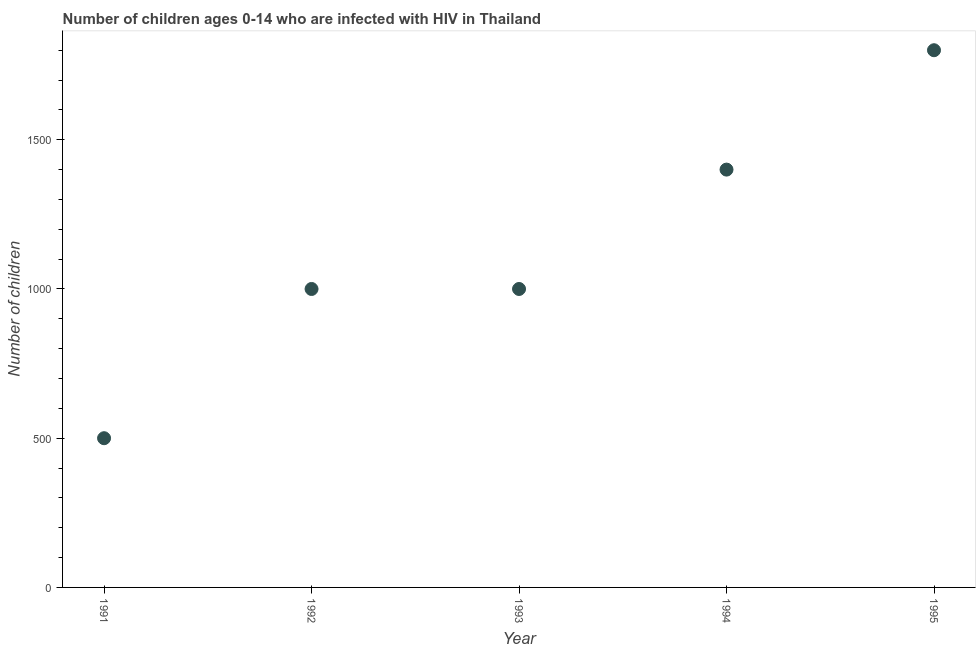What is the number of children living with hiv in 1994?
Keep it short and to the point. 1400. Across all years, what is the maximum number of children living with hiv?
Keep it short and to the point. 1800. Across all years, what is the minimum number of children living with hiv?
Make the answer very short. 500. What is the sum of the number of children living with hiv?
Provide a short and direct response. 5700. What is the difference between the number of children living with hiv in 1994 and 1995?
Offer a terse response. -400. What is the average number of children living with hiv per year?
Provide a succinct answer. 1140. In how many years, is the number of children living with hiv greater than 600 ?
Ensure brevity in your answer.  4. What is the ratio of the number of children living with hiv in 1992 to that in 1995?
Your response must be concise. 0.56. Is the difference between the number of children living with hiv in 1991 and 1995 greater than the difference between any two years?
Your answer should be compact. Yes. What is the difference between the highest and the second highest number of children living with hiv?
Offer a very short reply. 400. Is the sum of the number of children living with hiv in 1993 and 1994 greater than the maximum number of children living with hiv across all years?
Provide a succinct answer. Yes. What is the difference between the highest and the lowest number of children living with hiv?
Your answer should be compact. 1300. In how many years, is the number of children living with hiv greater than the average number of children living with hiv taken over all years?
Offer a very short reply. 2. Does the number of children living with hiv monotonically increase over the years?
Provide a short and direct response. No. How many years are there in the graph?
Keep it short and to the point. 5. What is the difference between two consecutive major ticks on the Y-axis?
Give a very brief answer. 500. Are the values on the major ticks of Y-axis written in scientific E-notation?
Keep it short and to the point. No. Does the graph contain grids?
Give a very brief answer. No. What is the title of the graph?
Your response must be concise. Number of children ages 0-14 who are infected with HIV in Thailand. What is the label or title of the Y-axis?
Keep it short and to the point. Number of children. What is the Number of children in 1992?
Offer a terse response. 1000. What is the Number of children in 1993?
Ensure brevity in your answer.  1000. What is the Number of children in 1994?
Your answer should be compact. 1400. What is the Number of children in 1995?
Keep it short and to the point. 1800. What is the difference between the Number of children in 1991 and 1992?
Make the answer very short. -500. What is the difference between the Number of children in 1991 and 1993?
Your answer should be compact. -500. What is the difference between the Number of children in 1991 and 1994?
Offer a very short reply. -900. What is the difference between the Number of children in 1991 and 1995?
Provide a succinct answer. -1300. What is the difference between the Number of children in 1992 and 1993?
Ensure brevity in your answer.  0. What is the difference between the Number of children in 1992 and 1994?
Provide a short and direct response. -400. What is the difference between the Number of children in 1992 and 1995?
Offer a very short reply. -800. What is the difference between the Number of children in 1993 and 1994?
Give a very brief answer. -400. What is the difference between the Number of children in 1993 and 1995?
Your answer should be compact. -800. What is the difference between the Number of children in 1994 and 1995?
Offer a very short reply. -400. What is the ratio of the Number of children in 1991 to that in 1994?
Your answer should be compact. 0.36. What is the ratio of the Number of children in 1991 to that in 1995?
Offer a very short reply. 0.28. What is the ratio of the Number of children in 1992 to that in 1993?
Keep it short and to the point. 1. What is the ratio of the Number of children in 1992 to that in 1994?
Give a very brief answer. 0.71. What is the ratio of the Number of children in 1992 to that in 1995?
Provide a short and direct response. 0.56. What is the ratio of the Number of children in 1993 to that in 1994?
Make the answer very short. 0.71. What is the ratio of the Number of children in 1993 to that in 1995?
Give a very brief answer. 0.56. What is the ratio of the Number of children in 1994 to that in 1995?
Your response must be concise. 0.78. 